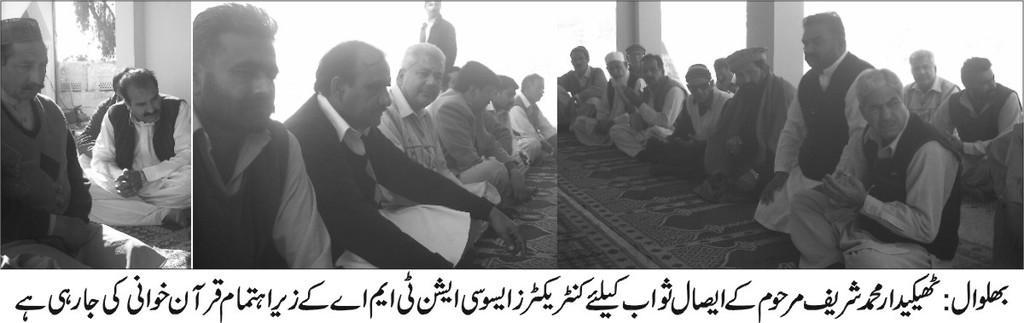Could you give a brief overview of what you see in this image? This picture is a black and white image. This picture shows the collage of three images. In this picture we can see some carpets on the floor, some people are sitting on the floor, one man standing, one wall, two people are in kneeling position, some text on the bottom of the picture, some trees and some objects on the ground. 